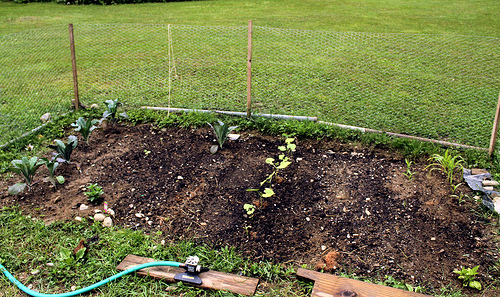<image>
Can you confirm if the pole is next to the garden? Yes. The pole is positioned adjacent to the garden, located nearby in the same general area. 